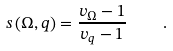<formula> <loc_0><loc_0><loc_500><loc_500>s \left ( \Omega , q \right ) = \frac { v _ { \Omega } - 1 } { v _ { q } - 1 } \quad .</formula> 